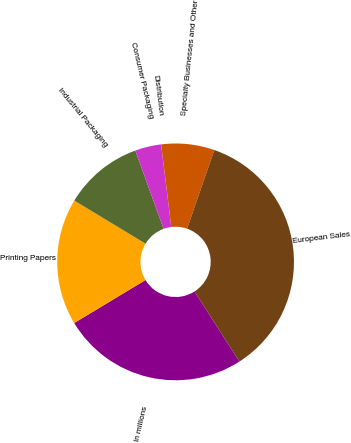Convert chart. <chart><loc_0><loc_0><loc_500><loc_500><pie_chart><fcel>In millions<fcel>Printing Papers<fcel>Industrial Packaging<fcel>Consumer Packaging<fcel>Distribution<fcel>Specialty Businesses and Other<fcel>European Sales<nl><fcel>25.43%<fcel>17.3%<fcel>10.81%<fcel>3.57%<fcel>0.01%<fcel>7.25%<fcel>35.62%<nl></chart> 